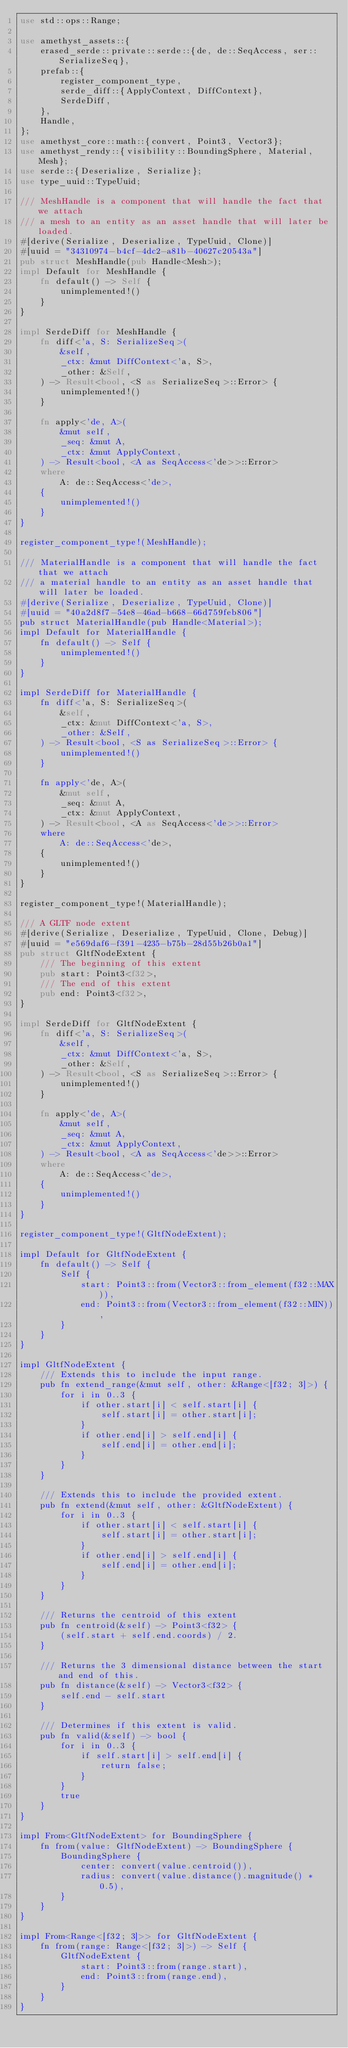<code> <loc_0><loc_0><loc_500><loc_500><_Rust_>use std::ops::Range;

use amethyst_assets::{
    erased_serde::private::serde::{de, de::SeqAccess, ser::SerializeSeq},
    prefab::{
        register_component_type,
        serde_diff::{ApplyContext, DiffContext},
        SerdeDiff,
    },
    Handle,
};
use amethyst_core::math::{convert, Point3, Vector3};
use amethyst_rendy::{visibility::BoundingSphere, Material, Mesh};
use serde::{Deserialize, Serialize};
use type_uuid::TypeUuid;

/// MeshHandle is a component that will handle the fact that we attach
/// a mesh to an entity as an asset handle that will later be loaded.
#[derive(Serialize, Deserialize, TypeUuid, Clone)]
#[uuid = "34310974-b4cf-4dc2-a81b-40627c20543a"]
pub struct MeshHandle(pub Handle<Mesh>);
impl Default for MeshHandle {
    fn default() -> Self {
        unimplemented!()
    }
}

impl SerdeDiff for MeshHandle {
    fn diff<'a, S: SerializeSeq>(
        &self,
        _ctx: &mut DiffContext<'a, S>,
        _other: &Self,
    ) -> Result<bool, <S as SerializeSeq>::Error> {
        unimplemented!()
    }

    fn apply<'de, A>(
        &mut self,
        _seq: &mut A,
        _ctx: &mut ApplyContext,
    ) -> Result<bool, <A as SeqAccess<'de>>::Error>
    where
        A: de::SeqAccess<'de>,
    {
        unimplemented!()
    }
}

register_component_type!(MeshHandle);

/// MaterialHandle is a component that will handle the fact that we attach
/// a material handle to an entity as an asset handle that will later be loaded.
#[derive(Serialize, Deserialize, TypeUuid, Clone)]
#[uuid = "40a2d8f7-54e8-46ad-b668-66d759feb806"]
pub struct MaterialHandle(pub Handle<Material>);
impl Default for MaterialHandle {
    fn default() -> Self {
        unimplemented!()
    }
}

impl SerdeDiff for MaterialHandle {
    fn diff<'a, S: SerializeSeq>(
        &self,
        _ctx: &mut DiffContext<'a, S>,
        _other: &Self,
    ) -> Result<bool, <S as SerializeSeq>::Error> {
        unimplemented!()
    }

    fn apply<'de, A>(
        &mut self,
        _seq: &mut A,
        _ctx: &mut ApplyContext,
    ) -> Result<bool, <A as SeqAccess<'de>>::Error>
    where
        A: de::SeqAccess<'de>,
    {
        unimplemented!()
    }
}

register_component_type!(MaterialHandle);

/// A GLTF node extent
#[derive(Serialize, Deserialize, TypeUuid, Clone, Debug)]
#[uuid = "e569daf6-f391-4235-b75b-28d55b26b0a1"]
pub struct GltfNodeExtent {
    /// The beginning of this extent
    pub start: Point3<f32>,
    /// The end of this extent
    pub end: Point3<f32>,
}

impl SerdeDiff for GltfNodeExtent {
    fn diff<'a, S: SerializeSeq>(
        &self,
        _ctx: &mut DiffContext<'a, S>,
        _other: &Self,
    ) -> Result<bool, <S as SerializeSeq>::Error> {
        unimplemented!()
    }

    fn apply<'de, A>(
        &mut self,
        _seq: &mut A,
        _ctx: &mut ApplyContext,
    ) -> Result<bool, <A as SeqAccess<'de>>::Error>
    where
        A: de::SeqAccess<'de>,
    {
        unimplemented!()
    }
}

register_component_type!(GltfNodeExtent);

impl Default for GltfNodeExtent {
    fn default() -> Self {
        Self {
            start: Point3::from(Vector3::from_element(f32::MAX)),
            end: Point3::from(Vector3::from_element(f32::MIN)),
        }
    }
}

impl GltfNodeExtent {
    /// Extends this to include the input range.
    pub fn extend_range(&mut self, other: &Range<[f32; 3]>) {
        for i in 0..3 {
            if other.start[i] < self.start[i] {
                self.start[i] = other.start[i];
            }
            if other.end[i] > self.end[i] {
                self.end[i] = other.end[i];
            }
        }
    }

    /// Extends this to include the provided extent.
    pub fn extend(&mut self, other: &GltfNodeExtent) {
        for i in 0..3 {
            if other.start[i] < self.start[i] {
                self.start[i] = other.start[i];
            }
            if other.end[i] > self.end[i] {
                self.end[i] = other.end[i];
            }
        }
    }

    /// Returns the centroid of this extent
    pub fn centroid(&self) -> Point3<f32> {
        (self.start + self.end.coords) / 2.
    }

    /// Returns the 3 dimensional distance between the start and end of this.
    pub fn distance(&self) -> Vector3<f32> {
        self.end - self.start
    }

    /// Determines if this extent is valid.
    pub fn valid(&self) -> bool {
        for i in 0..3 {
            if self.start[i] > self.end[i] {
                return false;
            }
        }
        true
    }
}

impl From<GltfNodeExtent> for BoundingSphere {
    fn from(value: GltfNodeExtent) -> BoundingSphere {
        BoundingSphere {
            center: convert(value.centroid()),
            radius: convert(value.distance().magnitude() * 0.5),
        }
    }
}

impl From<Range<[f32; 3]>> for GltfNodeExtent {
    fn from(range: Range<[f32; 3]>) -> Self {
        GltfNodeExtent {
            start: Point3::from(range.start),
            end: Point3::from(range.end),
        }
    }
}
</code> 